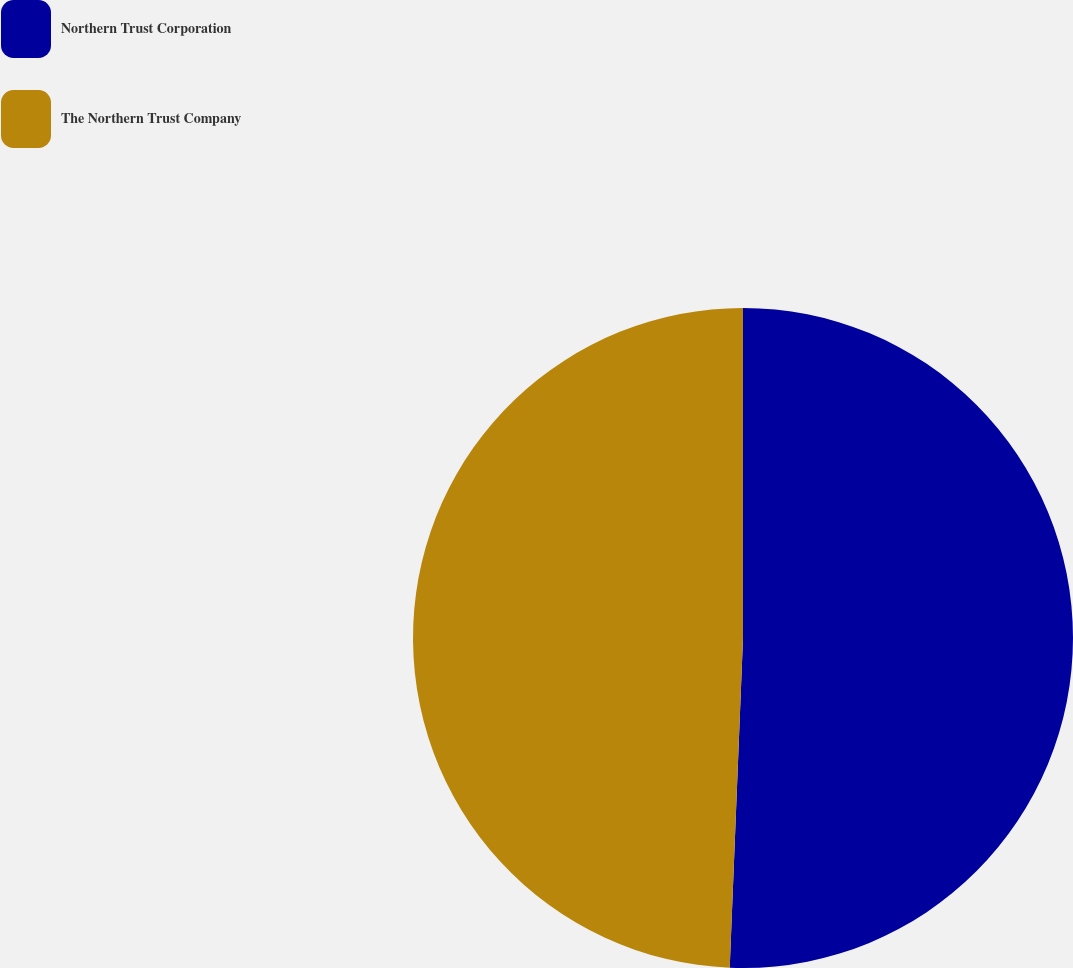Convert chart. <chart><loc_0><loc_0><loc_500><loc_500><pie_chart><fcel>Northern Trust Corporation<fcel>The Northern Trust Company<nl><fcel>50.64%<fcel>49.36%<nl></chart> 